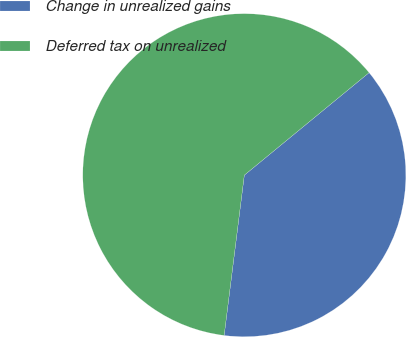<chart> <loc_0><loc_0><loc_500><loc_500><pie_chart><fcel>Change in unrealized gains<fcel>Deferred tax on unrealized<nl><fcel>37.94%<fcel>62.06%<nl></chart> 